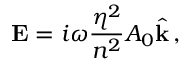<formula> <loc_0><loc_0><loc_500><loc_500>{ E } = i \omega \frac { \eta ^ { 2 } } { n ^ { 2 } } A _ { 0 } \hat { k } \, ,</formula> 